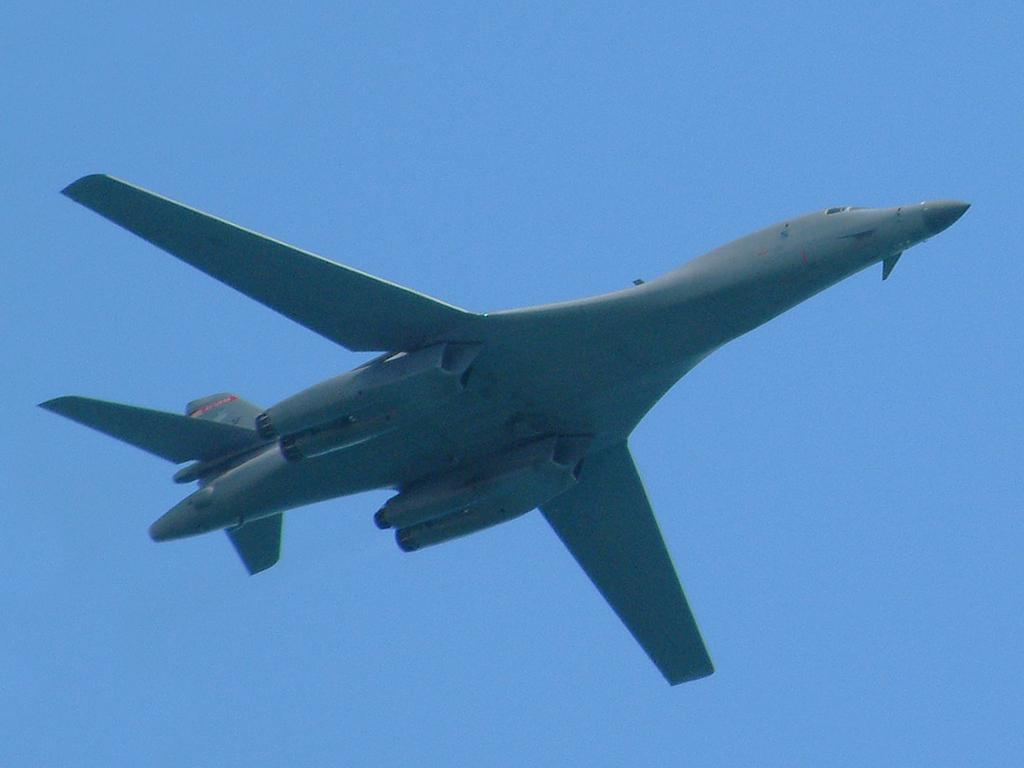What is the main subject of the image? The main subject of the image is an aircraft. What is the aircraft doing in the image? The aircraft is flying in the sky. What type of squirrel can be seen climbing on the aircraft in the image? There is no squirrel present on the aircraft in the image. What sound does the whistle make as the aircraft flies in the image? There is no whistle present in the image. 